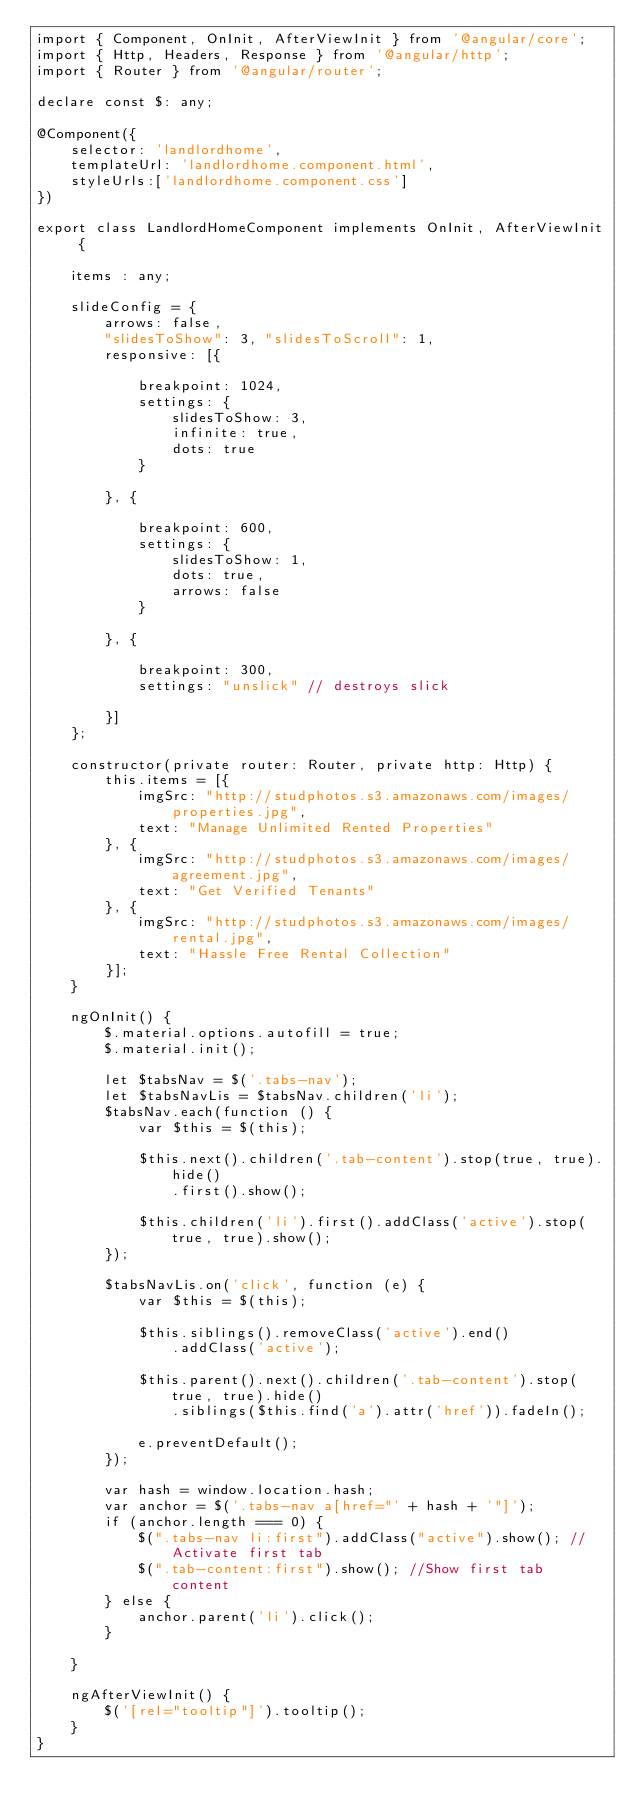Convert code to text. <code><loc_0><loc_0><loc_500><loc_500><_TypeScript_>import { Component, OnInit, AfterViewInit } from '@angular/core';
import { Http, Headers, Response } from '@angular/http';
import { Router } from '@angular/router';

declare const $: any;

@Component({
    selector: 'landlordhome',
    templateUrl: 'landlordhome.component.html',
    styleUrls:['landlordhome.component.css']
})

export class LandlordHomeComponent implements OnInit, AfterViewInit {

    items : any;

    slideConfig = {
        arrows: false,
        "slidesToShow": 3, "slidesToScroll": 1,
        responsive: [{

            breakpoint: 1024,
            settings: {
                slidesToShow: 3,
                infinite: true,
                dots: true
            }

        }, {

            breakpoint: 600,
            settings: {
                slidesToShow: 1,
                dots: true,
                arrows: false
            }

        }, {

            breakpoint: 300,
            settings: "unslick" // destroys slick

        }]
    };

    constructor(private router: Router, private http: Http) {
        this.items = [{
            imgSrc: "http://studphotos.s3.amazonaws.com/images/properties.jpg",
            text: "Manage Unlimited Rented Properties"
        }, {
            imgSrc: "http://studphotos.s3.amazonaws.com/images/agreement.jpg",
            text: "Get Verified Tenants"
        }, {
            imgSrc: "http://studphotos.s3.amazonaws.com/images/rental.jpg",
            text: "Hassle Free Rental Collection"
        }];     
    } 

    ngOnInit() {
        $.material.options.autofill = true;
        $.material.init();
        
        let $tabsNav = $('.tabs-nav');
        let $tabsNavLis = $tabsNav.children('li');
        $tabsNav.each(function () {
            var $this = $(this);

            $this.next().children('.tab-content').stop(true, true).hide()
                .first().show();

            $this.children('li').first().addClass('active').stop(true, true).show();
        });

        $tabsNavLis.on('click', function (e) {
            var $this = $(this);

            $this.siblings().removeClass('active').end()
                .addClass('active');

            $this.parent().next().children('.tab-content').stop(true, true).hide()
                .siblings($this.find('a').attr('href')).fadeIn();

            e.preventDefault();
        });

        var hash = window.location.hash;
        var anchor = $('.tabs-nav a[href="' + hash + '"]');
        if (anchor.length === 0) {
            $(".tabs-nav li:first").addClass("active").show(); //Activate first tab
            $(".tab-content:first").show(); //Show first tab content
        } else {
            anchor.parent('li').click();
        }
        
    }

    ngAfterViewInit() {
        $('[rel="tooltip"]').tooltip();
    }
}

</code> 